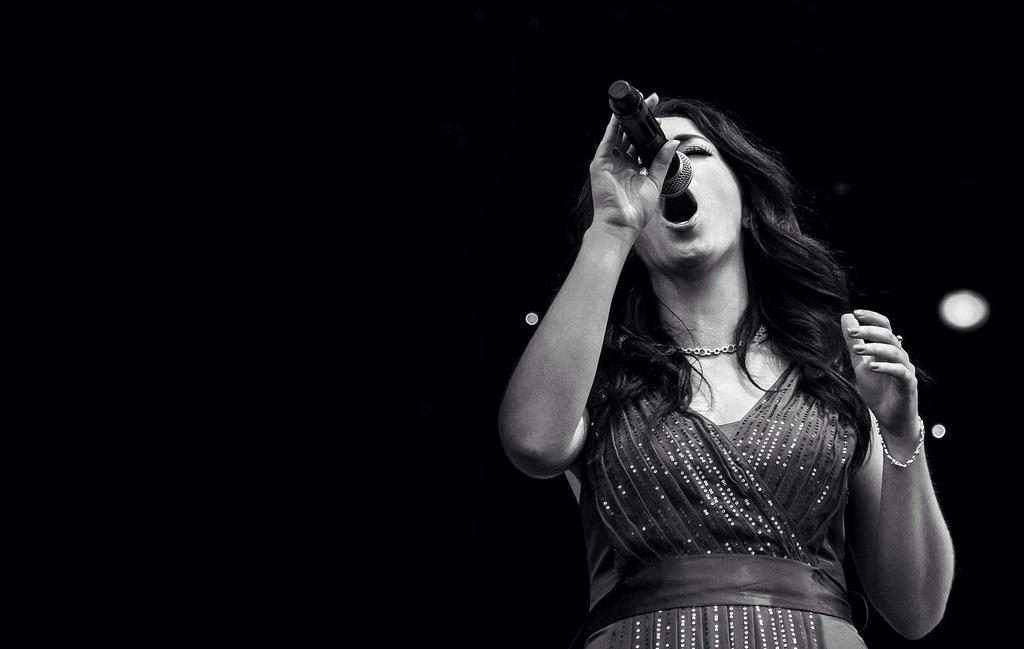Who is the main subject in the image? There is a woman in the image. Where is the woman positioned in the image? The woman is standing on the right side. What is the woman holding in the image? The woman is holding a microphone. What can be said about the color of the microphone? The microphone is black in color. What is the woman doing with the microphone? The woman is singing into the microphone. Can you tell me how many cows are present in the image? There are no cows present in the image; it features a woman holding a microphone. What type of heat source is visible in the image? There is no heat source visible in the image. 